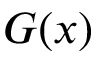Convert formula to latex. <formula><loc_0><loc_0><loc_500><loc_500>G ( x )</formula> 